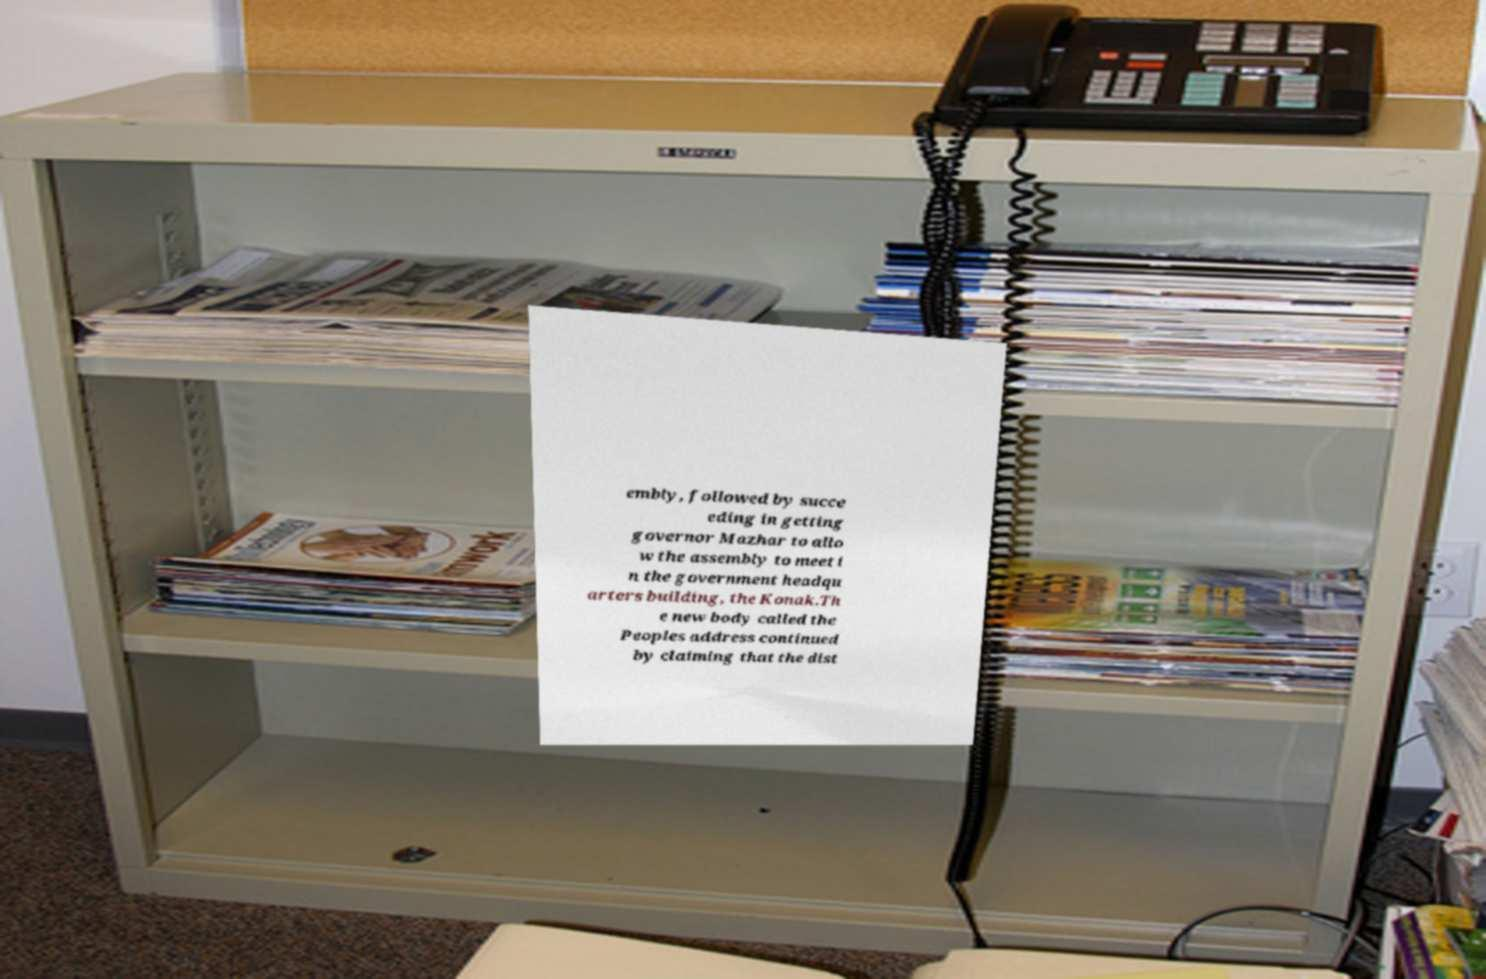For documentation purposes, I need the text within this image transcribed. Could you provide that? embly, followed by succe eding in getting governor Mazhar to allo w the assembly to meet i n the government headqu arters building, the Konak.Th e new body called the Peoples address continued by claiming that the dist 